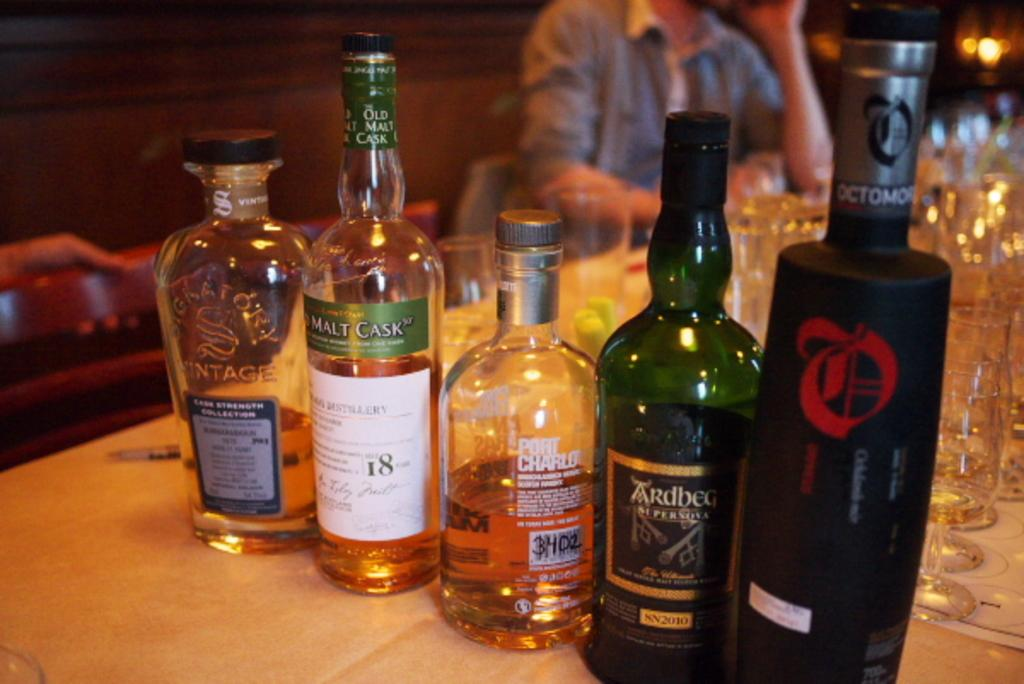<image>
Share a concise interpretation of the image provided. A row of alcohol bottles on a restaurant table including one that says Port Charlo. 